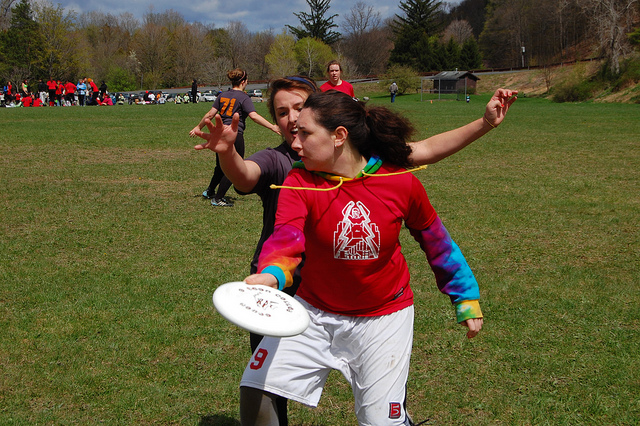Identify the text contained in this image. 9 